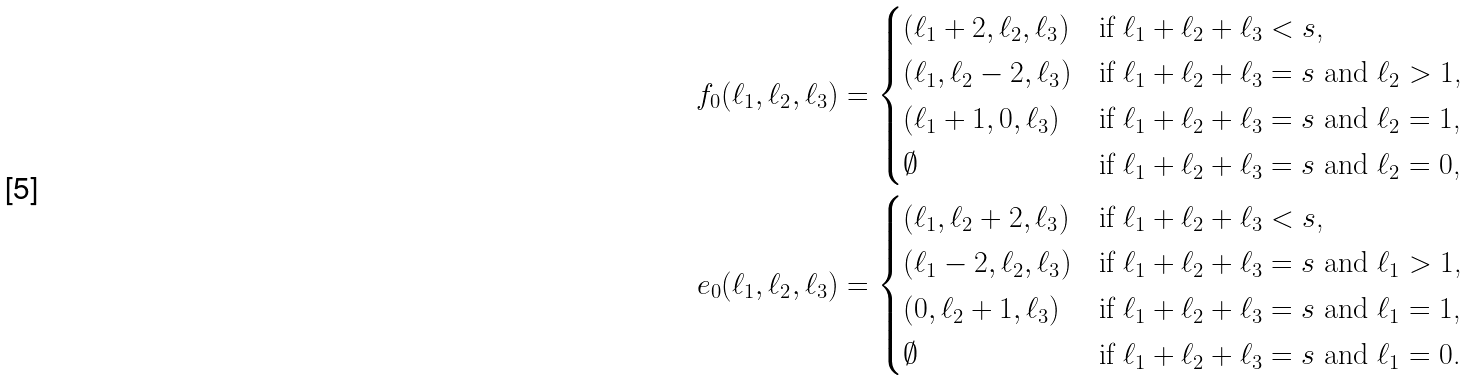<formula> <loc_0><loc_0><loc_500><loc_500>f _ { 0 } ( \ell _ { 1 } , \ell _ { 2 } , \ell _ { 3 } ) & = \begin{cases} ( \ell _ { 1 } + 2 , \ell _ { 2 } , \ell _ { 3 } ) & \text {if $\ell_{1} + \ell_{2} + \ell_{3} < s$,} \\ ( \ell _ { 1 } , \ell _ { 2 } - 2 , \ell _ { 3 } ) & \text {if $\ell_{1} + \ell_{2} + \ell_{3} = s$ and $\ell_{2} > 1$,} \\ ( \ell _ { 1 } + 1 , 0 , \ell _ { 3 } ) & \text {if $\ell_{1} + \ell_{2} + \ell_{3} = s$ and $\ell_{2} = 1$,} \\ \emptyset & \text {if $\ell_{1} + \ell_{2} + \ell_{3} = s$ and $\ell_{2}=0$,} \end{cases} \\ e _ { 0 } ( \ell _ { 1 } , \ell _ { 2 } , \ell _ { 3 } ) & = \begin{cases} ( \ell _ { 1 } , \ell _ { 2 } + 2 , \ell _ { 3 } ) & \text {if $\ell_{1} + \ell_{2} + \ell_{3} < s$,} \\ ( \ell _ { 1 } - 2 , \ell _ { 2 } , \ell _ { 3 } ) & \text {if $\ell_{1} + \ell_{2} + \ell_{3} = s$ and $\ell_{1} > 1$,} \\ ( 0 , \ell _ { 2 } + 1 , \ell _ { 3 } ) & \text {if $\ell_{1} + \ell_{2} + \ell_{3} = s$ and $\ell_{1} = 1$,} \\ \emptyset & \text {if $\ell_{1} + \ell_{2} + \ell_{3} = s$ and $\ell_{1}=0$.} \end{cases}</formula> 